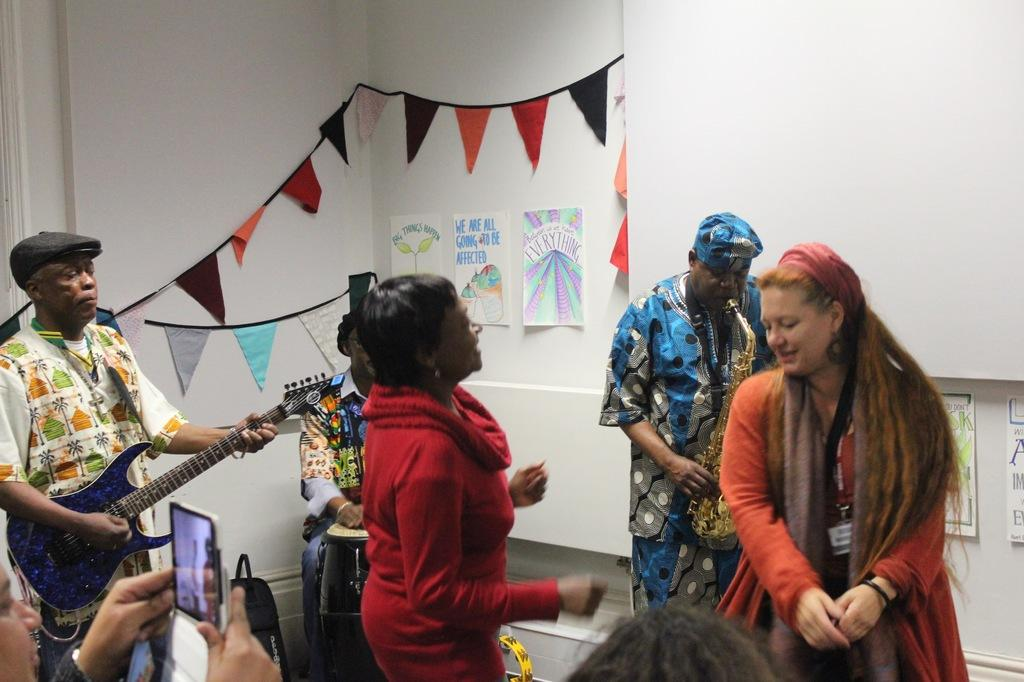What are the children doing in the image? The children are playing with a ball in the image. Where are the children playing? The children are playing on a playground in the image. What type of activity are the children engaged in? The children are playing a game with a ball in the image. What type of pest can be seen crawling on the playground equipment in the image? There is no pest visible on the playground equipment in the image. 